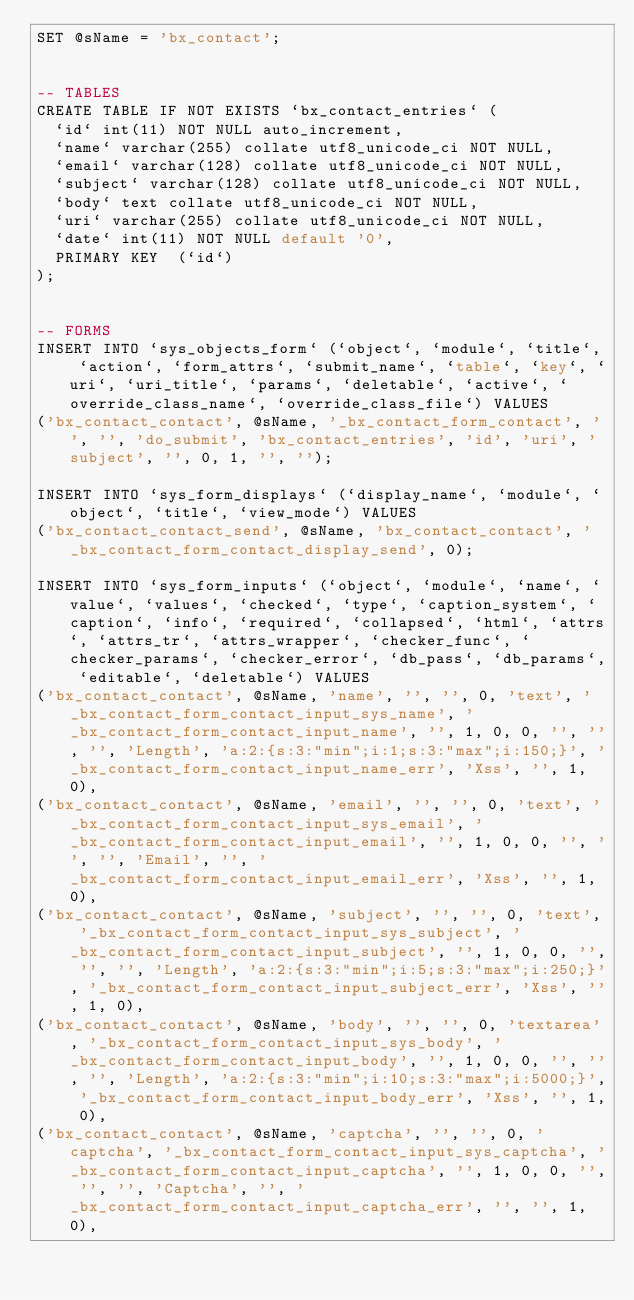<code> <loc_0><loc_0><loc_500><loc_500><_SQL_>SET @sName = 'bx_contact';


-- TABLES
CREATE TABLE IF NOT EXISTS `bx_contact_entries` (
  `id` int(11) NOT NULL auto_increment,
  `name` varchar(255) collate utf8_unicode_ci NOT NULL,
  `email` varchar(128) collate utf8_unicode_ci NOT NULL,
  `subject` varchar(128) collate utf8_unicode_ci NOT NULL,
  `body` text collate utf8_unicode_ci NOT NULL,
  `uri` varchar(255) collate utf8_unicode_ci NOT NULL,
  `date` int(11) NOT NULL default '0',
  PRIMARY KEY  (`id`)
);


-- FORMS
INSERT INTO `sys_objects_form` (`object`, `module`, `title`, `action`, `form_attrs`, `submit_name`, `table`, `key`, `uri`, `uri_title`, `params`, `deletable`, `active`, `override_class_name`, `override_class_file`) VALUES
('bx_contact_contact', @sName, '_bx_contact_form_contact', '', '', 'do_submit', 'bx_contact_entries', 'id', 'uri', 'subject', '', 0, 1, '', '');

INSERT INTO `sys_form_displays` (`display_name`, `module`, `object`, `title`, `view_mode`) VALUES
('bx_contact_contact_send', @sName, 'bx_contact_contact', '_bx_contact_form_contact_display_send', 0);

INSERT INTO `sys_form_inputs` (`object`, `module`, `name`, `value`, `values`, `checked`, `type`, `caption_system`, `caption`, `info`, `required`, `collapsed`, `html`, `attrs`, `attrs_tr`, `attrs_wrapper`, `checker_func`, `checker_params`, `checker_error`, `db_pass`, `db_params`, `editable`, `deletable`) VALUES
('bx_contact_contact', @sName, 'name', '', '', 0, 'text', '_bx_contact_form_contact_input_sys_name', '_bx_contact_form_contact_input_name', '', 1, 0, 0, '', '', '', 'Length', 'a:2:{s:3:"min";i:1;s:3:"max";i:150;}', '_bx_contact_form_contact_input_name_err', 'Xss', '', 1, 0),
('bx_contact_contact', @sName, 'email', '', '', 0, 'text', '_bx_contact_form_contact_input_sys_email', '_bx_contact_form_contact_input_email', '', 1, 0, 0, '', '', '', 'Email', '', '_bx_contact_form_contact_input_email_err', 'Xss', '', 1, 0),
('bx_contact_contact', @sName, 'subject', '', '', 0, 'text', '_bx_contact_form_contact_input_sys_subject', '_bx_contact_form_contact_input_subject', '', 1, 0, 0, '', '', '', 'Length', 'a:2:{s:3:"min";i:5;s:3:"max";i:250;}', '_bx_contact_form_contact_input_subject_err', 'Xss', '', 1, 0),
('bx_contact_contact', @sName, 'body', '', '', 0, 'textarea', '_bx_contact_form_contact_input_sys_body', '_bx_contact_form_contact_input_body', '', 1, 0, 0, '', '', '', 'Length', 'a:2:{s:3:"min";i:10;s:3:"max";i:5000;}', '_bx_contact_form_contact_input_body_err', 'Xss', '', 1, 0),
('bx_contact_contact', @sName, 'captcha', '', '', 0, 'captcha', '_bx_contact_form_contact_input_sys_captcha', '_bx_contact_form_contact_input_captcha', '', 1, 0, 0, '', '', '', 'Captcha', '', '_bx_contact_form_contact_input_captcha_err', '', '', 1, 0),</code> 